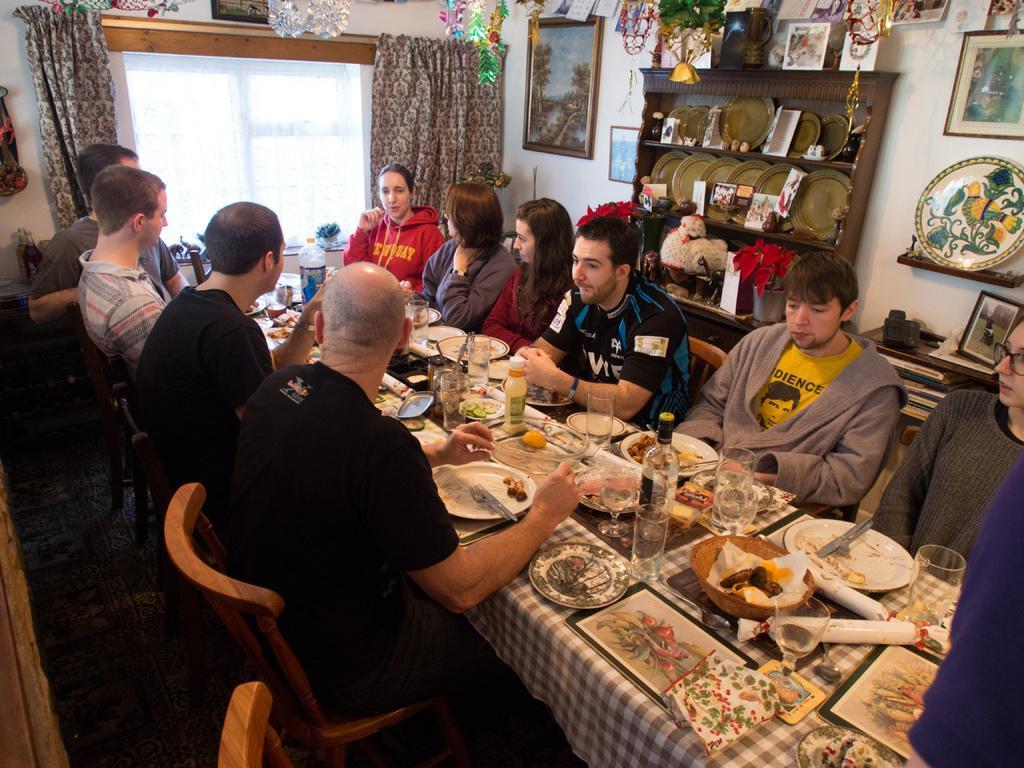In one or two sentences, can you explain what this image depicts? In this Image I see number of people who are sitting on chairs and there are tables in front of them on which there are many things, In the background I see the window, curtains, decoration, rack full of plates and other things, photo frames on the wall and books over here. 